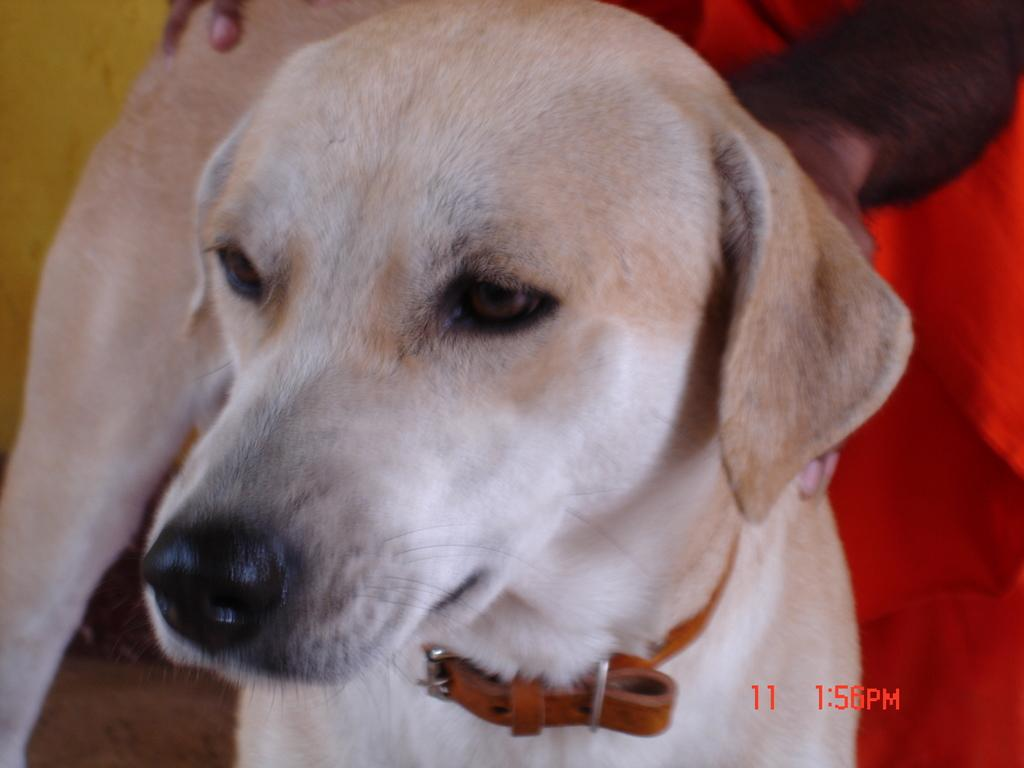What type of animal is in the image? There is a dog in the image. What can be seen in the background of the image? There are hands and a red cloth in the background of the image. Where is the time displayed in the image? The time is visible in the bottom right of the image. What type of prose is being recited by the dog in the image? There is no indication in the image that the dog is reciting any prose, as dogs do not have the ability to speak or recite literature. 